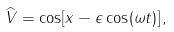Convert formula to latex. <formula><loc_0><loc_0><loc_500><loc_500>\widehat { V } = \cos [ x - \epsilon \cos ( \omega t ) ] \, ,</formula> 